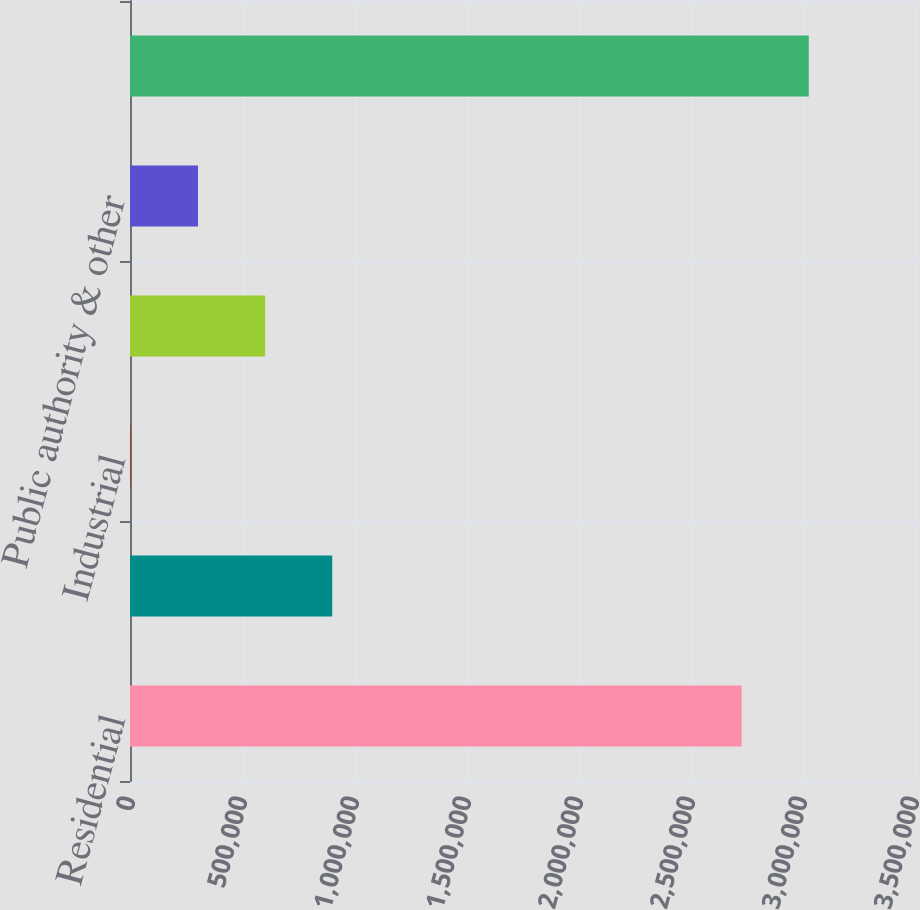Convert chart. <chart><loc_0><loc_0><loc_500><loc_500><bar_chart><fcel>Residential<fcel>Commercial<fcel>Industrial<fcel>Private fire<fcel>Public authority & other<fcel>Total<nl><fcel>2.73052e+06<fcel>902878<fcel>3885<fcel>603214<fcel>303549<fcel>3.03019e+06<nl></chart> 